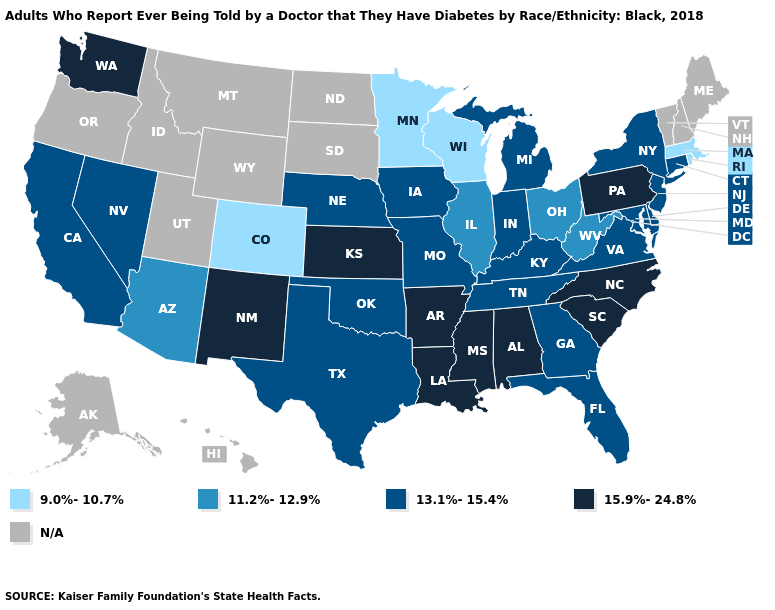Which states hav the highest value in the Northeast?
Concise answer only. Pennsylvania. Does the first symbol in the legend represent the smallest category?
Concise answer only. Yes. How many symbols are there in the legend?
Keep it brief. 5. Name the states that have a value in the range 11.2%-12.9%?
Be succinct. Arizona, Illinois, Ohio, West Virginia. What is the highest value in states that border Nevada?
Concise answer only. 13.1%-15.4%. What is the value of New Hampshire?
Write a very short answer. N/A. What is the value of Kentucky?
Be succinct. 13.1%-15.4%. What is the value of Indiana?
Answer briefly. 13.1%-15.4%. What is the lowest value in states that border Florida?
Quick response, please. 13.1%-15.4%. Which states have the lowest value in the USA?
Give a very brief answer. Colorado, Massachusetts, Minnesota, Rhode Island, Wisconsin. Does New Mexico have the lowest value in the USA?
Give a very brief answer. No. Name the states that have a value in the range N/A?
Be succinct. Alaska, Hawaii, Idaho, Maine, Montana, New Hampshire, North Dakota, Oregon, South Dakota, Utah, Vermont, Wyoming. Name the states that have a value in the range 9.0%-10.7%?
Be succinct. Colorado, Massachusetts, Minnesota, Rhode Island, Wisconsin. What is the highest value in the Northeast ?
Be succinct. 15.9%-24.8%. 